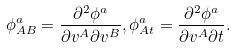<formula> <loc_0><loc_0><loc_500><loc_500>\phi _ { A B } ^ { a } = \frac { \partial ^ { 2 } \phi ^ { a } } { \partial v ^ { A } \partial v ^ { B } } , \phi _ { A t } ^ { a } = \frac { \partial ^ { 2 } \phi ^ { a } } { \partial v ^ { A } \partial t } .</formula> 